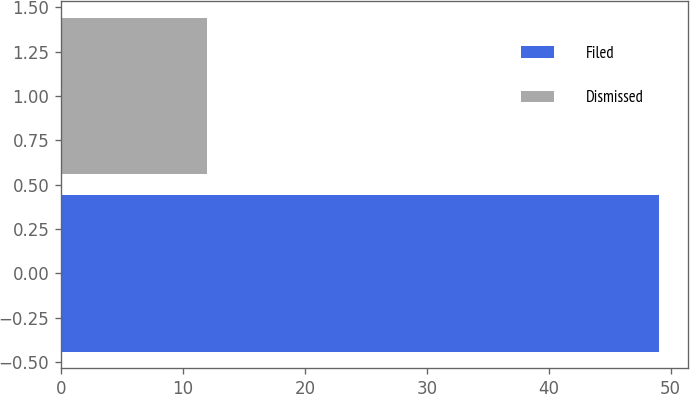<chart> <loc_0><loc_0><loc_500><loc_500><bar_chart><fcel>Filed<fcel>Dismissed<nl><fcel>49<fcel>12<nl></chart> 